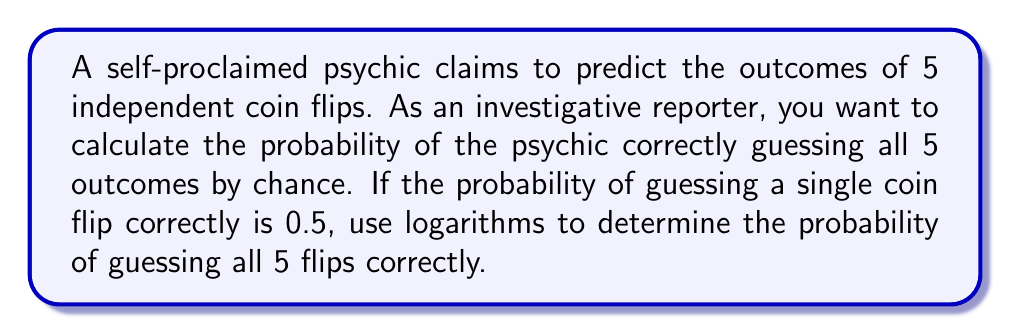Show me your answer to this math problem. Let's approach this step-by-step:

1) The probability of correctly guessing a single coin flip is 0.5.

2) For independent events, we multiply the individual probabilities. So, the probability of guessing all 5 flips correctly is:

   $$(0.5)^5$$

3) To calculate this using logarithms, we can use the following property:
   
   $$\log_a(x^n) = n\log_a(x)$$

4) Let's use base 10 logarithms. We want to find:

   $$\log_{10}((0.5)^5) = 5\log_{10}(0.5)$$

5) We can calculate $\log_{10}(0.5)$:

   $$\log_{10}(0.5) \approx -0.30103$$

6) Now, we multiply this by 5:

   $$5 \times (-0.30103) = -1.50515$$

7) This means:

   $$10^{-1.50515} \approx 0.03125$$

8) We can verify: $0.5 \times 0.5 \times 0.5 \times 0.5 \times 0.5 = 0.03125$

Therefore, the probability of the psychic correctly guessing all 5 coin flips by chance is approximately 0.03125 or 3.125%.
Answer: $0.03125$ or $3.125\%$ 